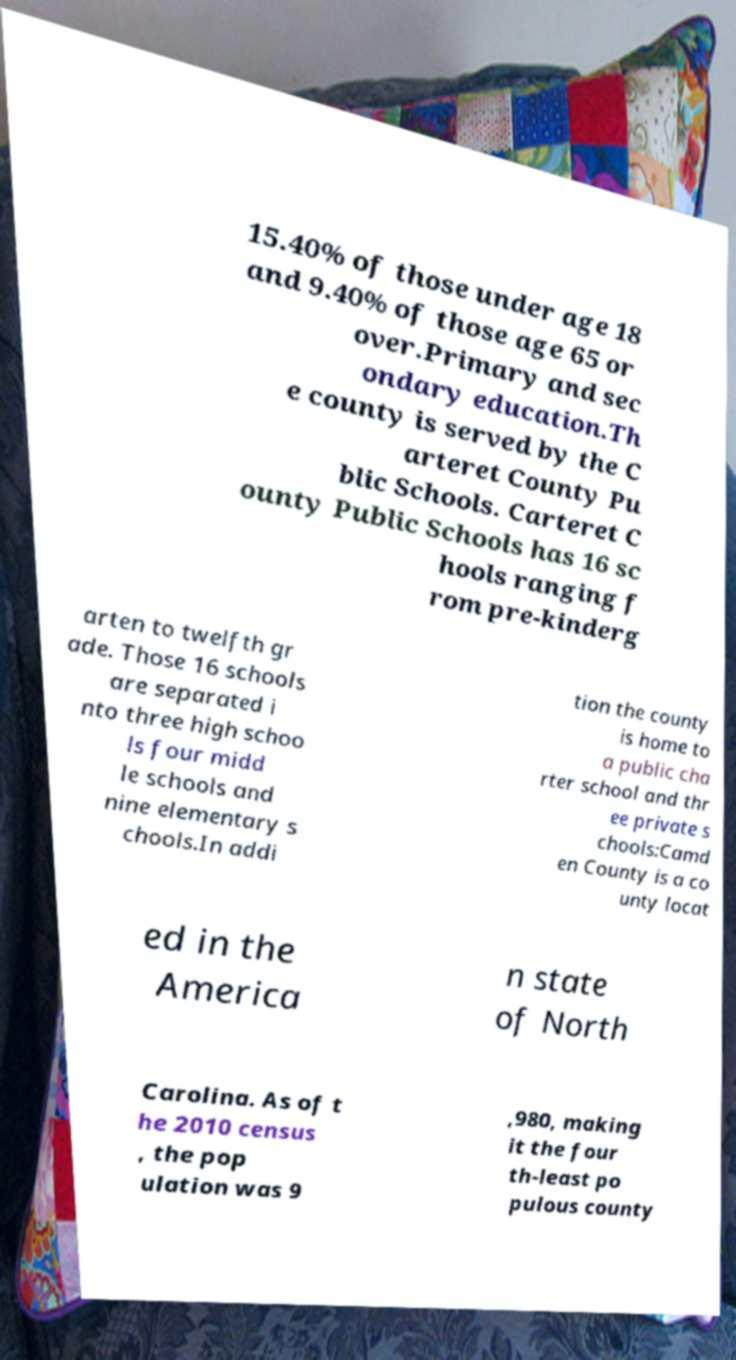I need the written content from this picture converted into text. Can you do that? 15.40% of those under age 18 and 9.40% of those age 65 or over.Primary and sec ondary education.Th e county is served by the C arteret County Pu blic Schools. Carteret C ounty Public Schools has 16 sc hools ranging f rom pre-kinderg arten to twelfth gr ade. Those 16 schools are separated i nto three high schoo ls four midd le schools and nine elementary s chools.In addi tion the county is home to a public cha rter school and thr ee private s chools:Camd en County is a co unty locat ed in the America n state of North Carolina. As of t he 2010 census , the pop ulation was 9 ,980, making it the four th-least po pulous county 